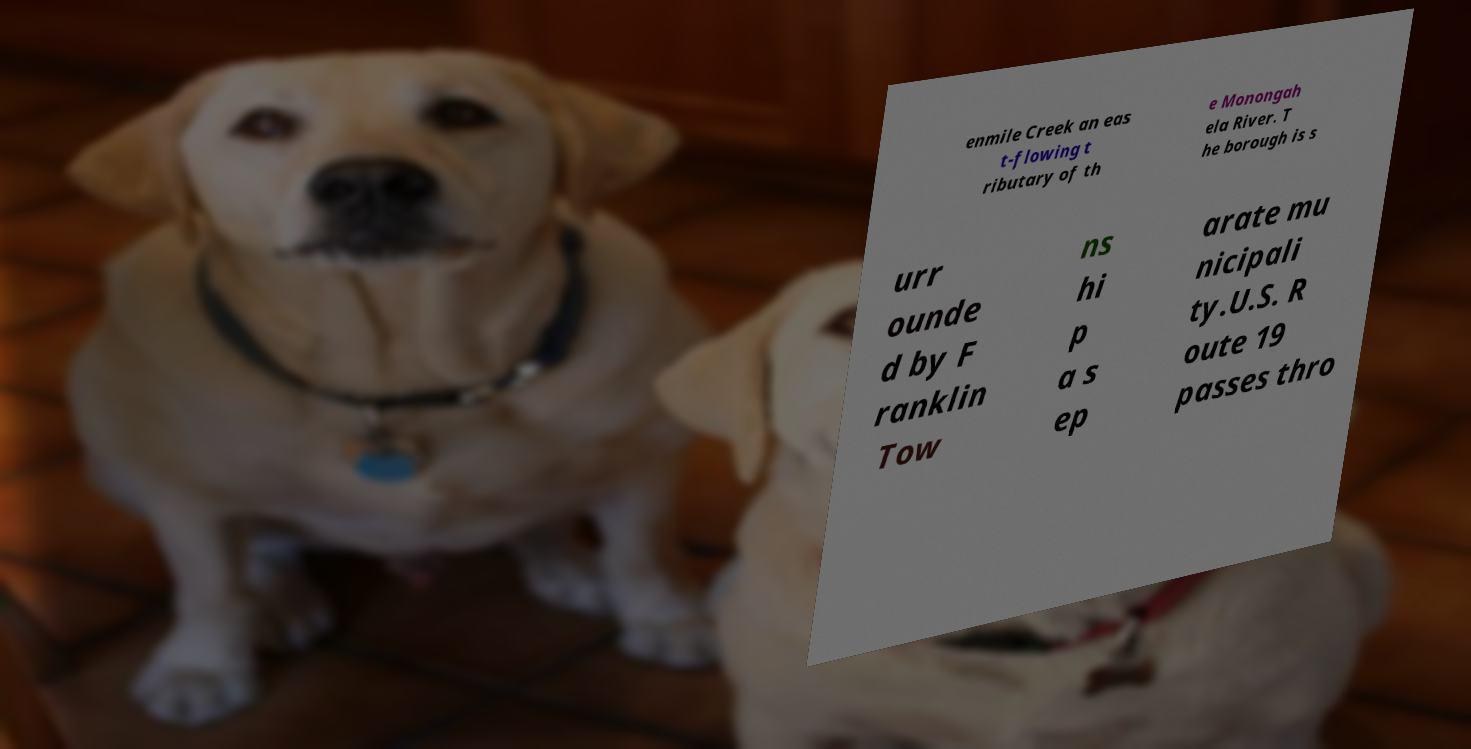Can you accurately transcribe the text from the provided image for me? enmile Creek an eas t-flowing t ributary of th e Monongah ela River. T he borough is s urr ounde d by F ranklin Tow ns hi p a s ep arate mu nicipali ty.U.S. R oute 19 passes thro 